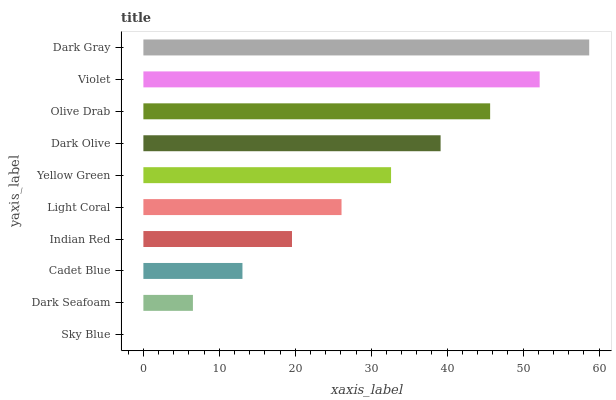Is Sky Blue the minimum?
Answer yes or no. Yes. Is Dark Gray the maximum?
Answer yes or no. Yes. Is Dark Seafoam the minimum?
Answer yes or no. No. Is Dark Seafoam the maximum?
Answer yes or no. No. Is Dark Seafoam greater than Sky Blue?
Answer yes or no. Yes. Is Sky Blue less than Dark Seafoam?
Answer yes or no. Yes. Is Sky Blue greater than Dark Seafoam?
Answer yes or no. No. Is Dark Seafoam less than Sky Blue?
Answer yes or no. No. Is Yellow Green the high median?
Answer yes or no. Yes. Is Light Coral the low median?
Answer yes or no. Yes. Is Violet the high median?
Answer yes or no. No. Is Olive Drab the low median?
Answer yes or no. No. 